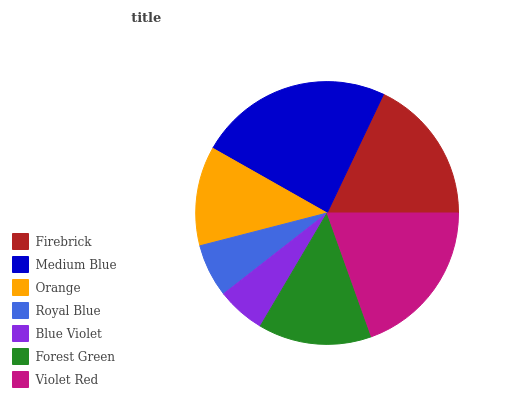Is Blue Violet the minimum?
Answer yes or no. Yes. Is Medium Blue the maximum?
Answer yes or no. Yes. Is Orange the minimum?
Answer yes or no. No. Is Orange the maximum?
Answer yes or no. No. Is Medium Blue greater than Orange?
Answer yes or no. Yes. Is Orange less than Medium Blue?
Answer yes or no. Yes. Is Orange greater than Medium Blue?
Answer yes or no. No. Is Medium Blue less than Orange?
Answer yes or no. No. Is Forest Green the high median?
Answer yes or no. Yes. Is Forest Green the low median?
Answer yes or no. Yes. Is Firebrick the high median?
Answer yes or no. No. Is Royal Blue the low median?
Answer yes or no. No. 